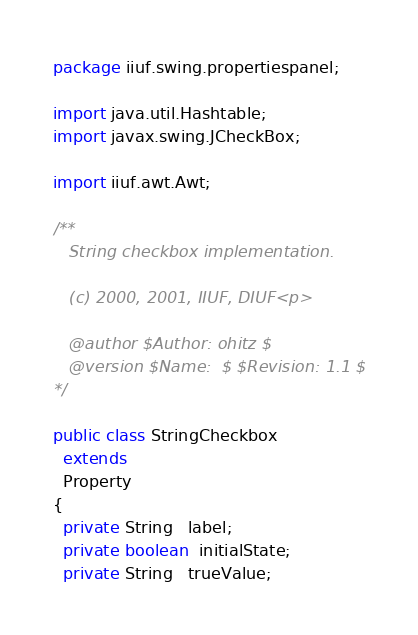<code> <loc_0><loc_0><loc_500><loc_500><_Java_>package iiuf.swing.propertiespanel;

import java.util.Hashtable;
import javax.swing.JCheckBox;

import iiuf.awt.Awt;

/**
   String checkbox implementation.

   (c) 2000, 2001, IIUF, DIUF<p>

   @author $Author: ohitz $
   @version $Name:  $ $Revision: 1.1 $
*/

public class StringCheckbox
  extends
  Property
{
  private String   label;
  private boolean  initialState;
  private String   trueValue;</code> 